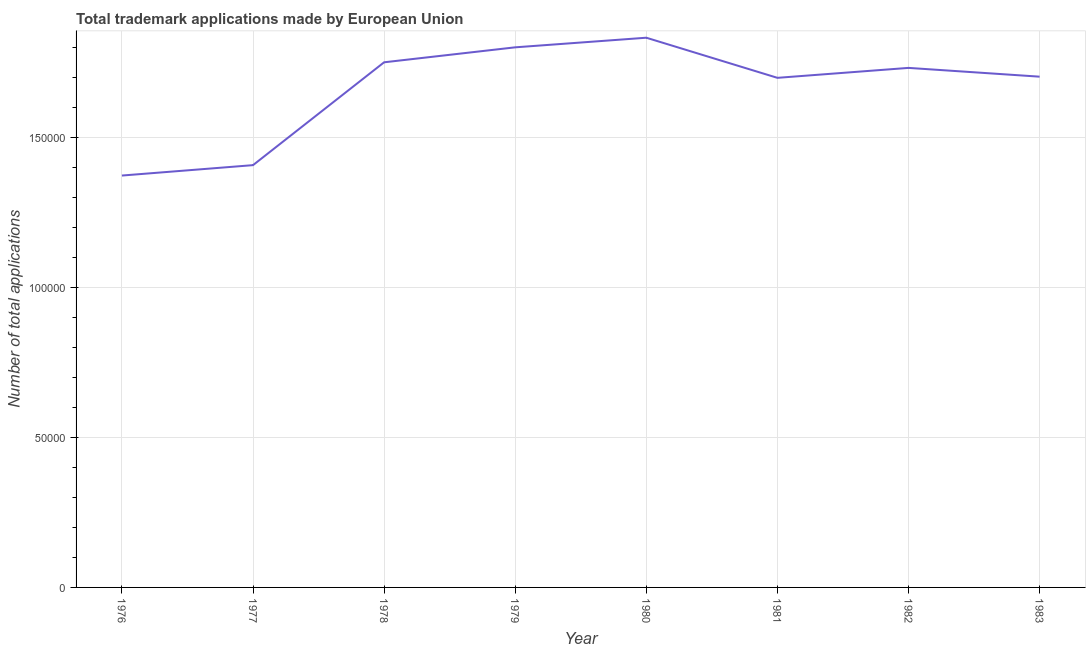What is the number of trademark applications in 1977?
Provide a succinct answer. 1.41e+05. Across all years, what is the maximum number of trademark applications?
Offer a terse response. 1.83e+05. Across all years, what is the minimum number of trademark applications?
Your answer should be compact. 1.37e+05. In which year was the number of trademark applications maximum?
Keep it short and to the point. 1980. In which year was the number of trademark applications minimum?
Offer a very short reply. 1976. What is the sum of the number of trademark applications?
Provide a short and direct response. 1.33e+06. What is the difference between the number of trademark applications in 1978 and 1979?
Provide a short and direct response. -4989. What is the average number of trademark applications per year?
Make the answer very short. 1.66e+05. What is the median number of trademark applications?
Offer a terse response. 1.72e+05. Do a majority of the years between 1979 and 1983 (inclusive) have number of trademark applications greater than 130000 ?
Ensure brevity in your answer.  Yes. What is the ratio of the number of trademark applications in 1982 to that in 1983?
Make the answer very short. 1.02. Is the number of trademark applications in 1977 less than that in 1981?
Keep it short and to the point. Yes. Is the difference between the number of trademark applications in 1979 and 1981 greater than the difference between any two years?
Keep it short and to the point. No. What is the difference between the highest and the second highest number of trademark applications?
Make the answer very short. 3204. Is the sum of the number of trademark applications in 1982 and 1983 greater than the maximum number of trademark applications across all years?
Your answer should be compact. Yes. What is the difference between the highest and the lowest number of trademark applications?
Provide a short and direct response. 4.59e+04. Does the number of trademark applications monotonically increase over the years?
Provide a short and direct response. No. What is the difference between two consecutive major ticks on the Y-axis?
Your response must be concise. 5.00e+04. What is the title of the graph?
Offer a terse response. Total trademark applications made by European Union. What is the label or title of the X-axis?
Offer a very short reply. Year. What is the label or title of the Y-axis?
Your response must be concise. Number of total applications. What is the Number of total applications of 1976?
Ensure brevity in your answer.  1.37e+05. What is the Number of total applications of 1977?
Ensure brevity in your answer.  1.41e+05. What is the Number of total applications of 1978?
Offer a terse response. 1.75e+05. What is the Number of total applications in 1979?
Your answer should be compact. 1.80e+05. What is the Number of total applications of 1980?
Your response must be concise. 1.83e+05. What is the Number of total applications in 1981?
Provide a succinct answer. 1.70e+05. What is the Number of total applications in 1982?
Provide a short and direct response. 1.73e+05. What is the Number of total applications of 1983?
Ensure brevity in your answer.  1.70e+05. What is the difference between the Number of total applications in 1976 and 1977?
Your answer should be compact. -3467. What is the difference between the Number of total applications in 1976 and 1978?
Your response must be concise. -3.77e+04. What is the difference between the Number of total applications in 1976 and 1979?
Offer a very short reply. -4.27e+04. What is the difference between the Number of total applications in 1976 and 1980?
Your answer should be compact. -4.59e+04. What is the difference between the Number of total applications in 1976 and 1981?
Your answer should be compact. -3.26e+04. What is the difference between the Number of total applications in 1976 and 1982?
Make the answer very short. -3.59e+04. What is the difference between the Number of total applications in 1976 and 1983?
Your answer should be compact. -3.30e+04. What is the difference between the Number of total applications in 1977 and 1978?
Make the answer very short. -3.43e+04. What is the difference between the Number of total applications in 1977 and 1979?
Offer a terse response. -3.93e+04. What is the difference between the Number of total applications in 1977 and 1980?
Keep it short and to the point. -4.25e+04. What is the difference between the Number of total applications in 1977 and 1981?
Provide a succinct answer. -2.91e+04. What is the difference between the Number of total applications in 1977 and 1982?
Your answer should be compact. -3.24e+04. What is the difference between the Number of total applications in 1977 and 1983?
Offer a very short reply. -2.95e+04. What is the difference between the Number of total applications in 1978 and 1979?
Your response must be concise. -4989. What is the difference between the Number of total applications in 1978 and 1980?
Your response must be concise. -8193. What is the difference between the Number of total applications in 1978 and 1981?
Give a very brief answer. 5179. What is the difference between the Number of total applications in 1978 and 1982?
Your answer should be compact. 1863. What is the difference between the Number of total applications in 1978 and 1983?
Your answer should be very brief. 4790. What is the difference between the Number of total applications in 1979 and 1980?
Your answer should be compact. -3204. What is the difference between the Number of total applications in 1979 and 1981?
Your answer should be compact. 1.02e+04. What is the difference between the Number of total applications in 1979 and 1982?
Offer a terse response. 6852. What is the difference between the Number of total applications in 1979 and 1983?
Keep it short and to the point. 9779. What is the difference between the Number of total applications in 1980 and 1981?
Give a very brief answer. 1.34e+04. What is the difference between the Number of total applications in 1980 and 1982?
Make the answer very short. 1.01e+04. What is the difference between the Number of total applications in 1980 and 1983?
Provide a succinct answer. 1.30e+04. What is the difference between the Number of total applications in 1981 and 1982?
Make the answer very short. -3316. What is the difference between the Number of total applications in 1981 and 1983?
Your answer should be compact. -389. What is the difference between the Number of total applications in 1982 and 1983?
Provide a succinct answer. 2927. What is the ratio of the Number of total applications in 1976 to that in 1978?
Your answer should be compact. 0.78. What is the ratio of the Number of total applications in 1976 to that in 1979?
Give a very brief answer. 0.76. What is the ratio of the Number of total applications in 1976 to that in 1980?
Your response must be concise. 0.75. What is the ratio of the Number of total applications in 1976 to that in 1981?
Make the answer very short. 0.81. What is the ratio of the Number of total applications in 1976 to that in 1982?
Offer a terse response. 0.79. What is the ratio of the Number of total applications in 1976 to that in 1983?
Give a very brief answer. 0.81. What is the ratio of the Number of total applications in 1977 to that in 1978?
Provide a succinct answer. 0.8. What is the ratio of the Number of total applications in 1977 to that in 1979?
Provide a short and direct response. 0.78. What is the ratio of the Number of total applications in 1977 to that in 1980?
Make the answer very short. 0.77. What is the ratio of the Number of total applications in 1977 to that in 1981?
Make the answer very short. 0.83. What is the ratio of the Number of total applications in 1977 to that in 1982?
Ensure brevity in your answer.  0.81. What is the ratio of the Number of total applications in 1977 to that in 1983?
Offer a terse response. 0.83. What is the ratio of the Number of total applications in 1978 to that in 1980?
Your response must be concise. 0.95. What is the ratio of the Number of total applications in 1978 to that in 1983?
Keep it short and to the point. 1.03. What is the ratio of the Number of total applications in 1979 to that in 1981?
Provide a short and direct response. 1.06. What is the ratio of the Number of total applications in 1979 to that in 1983?
Provide a succinct answer. 1.06. What is the ratio of the Number of total applications in 1980 to that in 1981?
Provide a short and direct response. 1.08. What is the ratio of the Number of total applications in 1980 to that in 1982?
Keep it short and to the point. 1.06. What is the ratio of the Number of total applications in 1980 to that in 1983?
Make the answer very short. 1.08. What is the ratio of the Number of total applications in 1982 to that in 1983?
Your response must be concise. 1.02. 